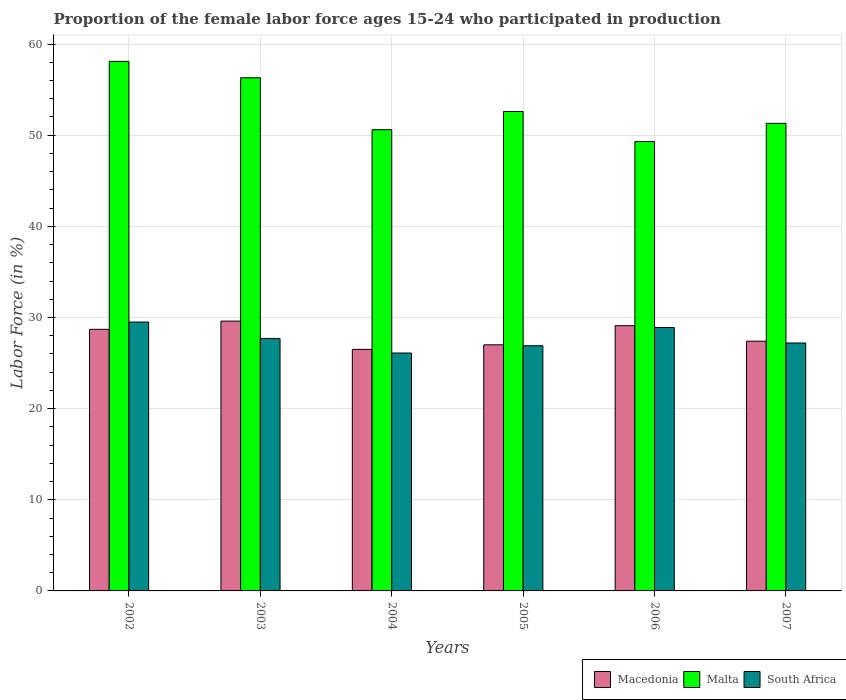How many different coloured bars are there?
Your answer should be compact. 3. Are the number of bars on each tick of the X-axis equal?
Offer a terse response. Yes. In how many cases, is the number of bars for a given year not equal to the number of legend labels?
Make the answer very short. 0. What is the proportion of the female labor force who participated in production in South Africa in 2007?
Give a very brief answer. 27.2. Across all years, what is the maximum proportion of the female labor force who participated in production in Malta?
Make the answer very short. 58.1. Across all years, what is the minimum proportion of the female labor force who participated in production in South Africa?
Provide a short and direct response. 26.1. In which year was the proportion of the female labor force who participated in production in Macedonia maximum?
Your answer should be very brief. 2003. In which year was the proportion of the female labor force who participated in production in South Africa minimum?
Offer a very short reply. 2004. What is the total proportion of the female labor force who participated in production in Macedonia in the graph?
Make the answer very short. 168.3. What is the difference between the proportion of the female labor force who participated in production in South Africa in 2003 and that in 2007?
Make the answer very short. 0.5. What is the difference between the proportion of the female labor force who participated in production in Macedonia in 2007 and the proportion of the female labor force who participated in production in South Africa in 2002?
Provide a succinct answer. -2.1. What is the average proportion of the female labor force who participated in production in Macedonia per year?
Make the answer very short. 28.05. In the year 2003, what is the difference between the proportion of the female labor force who participated in production in Macedonia and proportion of the female labor force who participated in production in South Africa?
Provide a short and direct response. 1.9. In how many years, is the proportion of the female labor force who participated in production in Macedonia greater than 24 %?
Your answer should be very brief. 6. What is the ratio of the proportion of the female labor force who participated in production in Macedonia in 2002 to that in 2003?
Ensure brevity in your answer.  0.97. Is the proportion of the female labor force who participated in production in Macedonia in 2004 less than that in 2006?
Make the answer very short. Yes. What is the difference between the highest and the second highest proportion of the female labor force who participated in production in Malta?
Provide a succinct answer. 1.8. What is the difference between the highest and the lowest proportion of the female labor force who participated in production in South Africa?
Offer a terse response. 3.4. What does the 2nd bar from the left in 2007 represents?
Provide a short and direct response. Malta. What does the 1st bar from the right in 2007 represents?
Keep it short and to the point. South Africa. How many bars are there?
Ensure brevity in your answer.  18. How many years are there in the graph?
Offer a very short reply. 6. What is the difference between two consecutive major ticks on the Y-axis?
Keep it short and to the point. 10. Are the values on the major ticks of Y-axis written in scientific E-notation?
Provide a succinct answer. No. Does the graph contain grids?
Your answer should be very brief. Yes. Where does the legend appear in the graph?
Ensure brevity in your answer.  Bottom right. How many legend labels are there?
Ensure brevity in your answer.  3. How are the legend labels stacked?
Your response must be concise. Horizontal. What is the title of the graph?
Provide a short and direct response. Proportion of the female labor force ages 15-24 who participated in production. Does "Iraq" appear as one of the legend labels in the graph?
Offer a very short reply. No. What is the label or title of the Y-axis?
Provide a short and direct response. Labor Force (in %). What is the Labor Force (in %) in Macedonia in 2002?
Make the answer very short. 28.7. What is the Labor Force (in %) in Malta in 2002?
Provide a short and direct response. 58.1. What is the Labor Force (in %) of South Africa in 2002?
Your answer should be very brief. 29.5. What is the Labor Force (in %) in Macedonia in 2003?
Ensure brevity in your answer.  29.6. What is the Labor Force (in %) in Malta in 2003?
Your answer should be very brief. 56.3. What is the Labor Force (in %) of South Africa in 2003?
Your response must be concise. 27.7. What is the Labor Force (in %) of Macedonia in 2004?
Offer a very short reply. 26.5. What is the Labor Force (in %) in Malta in 2004?
Your answer should be very brief. 50.6. What is the Labor Force (in %) in South Africa in 2004?
Your answer should be compact. 26.1. What is the Labor Force (in %) of Macedonia in 2005?
Give a very brief answer. 27. What is the Labor Force (in %) of Malta in 2005?
Give a very brief answer. 52.6. What is the Labor Force (in %) in South Africa in 2005?
Ensure brevity in your answer.  26.9. What is the Labor Force (in %) of Macedonia in 2006?
Make the answer very short. 29.1. What is the Labor Force (in %) of Malta in 2006?
Ensure brevity in your answer.  49.3. What is the Labor Force (in %) in South Africa in 2006?
Your answer should be compact. 28.9. What is the Labor Force (in %) in Macedonia in 2007?
Your answer should be compact. 27.4. What is the Labor Force (in %) in Malta in 2007?
Your answer should be compact. 51.3. What is the Labor Force (in %) of South Africa in 2007?
Offer a terse response. 27.2. Across all years, what is the maximum Labor Force (in %) in Macedonia?
Keep it short and to the point. 29.6. Across all years, what is the maximum Labor Force (in %) in Malta?
Your response must be concise. 58.1. Across all years, what is the maximum Labor Force (in %) of South Africa?
Your response must be concise. 29.5. Across all years, what is the minimum Labor Force (in %) in Malta?
Your answer should be very brief. 49.3. Across all years, what is the minimum Labor Force (in %) in South Africa?
Your answer should be very brief. 26.1. What is the total Labor Force (in %) in Macedonia in the graph?
Make the answer very short. 168.3. What is the total Labor Force (in %) of Malta in the graph?
Your answer should be compact. 318.2. What is the total Labor Force (in %) of South Africa in the graph?
Ensure brevity in your answer.  166.3. What is the difference between the Labor Force (in %) in South Africa in 2002 and that in 2003?
Your answer should be compact. 1.8. What is the difference between the Labor Force (in %) in Macedonia in 2002 and that in 2004?
Offer a terse response. 2.2. What is the difference between the Labor Force (in %) of Malta in 2002 and that in 2004?
Provide a succinct answer. 7.5. What is the difference between the Labor Force (in %) of Macedonia in 2002 and that in 2005?
Provide a succinct answer. 1.7. What is the difference between the Labor Force (in %) of Macedonia in 2002 and that in 2006?
Your answer should be compact. -0.4. What is the difference between the Labor Force (in %) in Malta in 2002 and that in 2006?
Provide a succinct answer. 8.8. What is the difference between the Labor Force (in %) of Macedonia in 2002 and that in 2007?
Ensure brevity in your answer.  1.3. What is the difference between the Labor Force (in %) in Malta in 2002 and that in 2007?
Provide a short and direct response. 6.8. What is the difference between the Labor Force (in %) in South Africa in 2002 and that in 2007?
Provide a short and direct response. 2.3. What is the difference between the Labor Force (in %) of South Africa in 2003 and that in 2004?
Offer a very short reply. 1.6. What is the difference between the Labor Force (in %) in Macedonia in 2003 and that in 2005?
Keep it short and to the point. 2.6. What is the difference between the Labor Force (in %) of Malta in 2003 and that in 2005?
Give a very brief answer. 3.7. What is the difference between the Labor Force (in %) in South Africa in 2003 and that in 2005?
Your answer should be very brief. 0.8. What is the difference between the Labor Force (in %) of Macedonia in 2003 and that in 2006?
Your response must be concise. 0.5. What is the difference between the Labor Force (in %) in Malta in 2003 and that in 2006?
Provide a short and direct response. 7. What is the difference between the Labor Force (in %) in South Africa in 2003 and that in 2006?
Offer a very short reply. -1.2. What is the difference between the Labor Force (in %) in Macedonia in 2003 and that in 2007?
Your answer should be very brief. 2.2. What is the difference between the Labor Force (in %) of Malta in 2003 and that in 2007?
Offer a terse response. 5. What is the difference between the Labor Force (in %) in South Africa in 2003 and that in 2007?
Ensure brevity in your answer.  0.5. What is the difference between the Labor Force (in %) in Macedonia in 2004 and that in 2005?
Your response must be concise. -0.5. What is the difference between the Labor Force (in %) in South Africa in 2004 and that in 2006?
Offer a very short reply. -2.8. What is the difference between the Labor Force (in %) of South Africa in 2004 and that in 2007?
Your answer should be compact. -1.1. What is the difference between the Labor Force (in %) in Macedonia in 2006 and that in 2007?
Your answer should be very brief. 1.7. What is the difference between the Labor Force (in %) of Malta in 2006 and that in 2007?
Keep it short and to the point. -2. What is the difference between the Labor Force (in %) of Macedonia in 2002 and the Labor Force (in %) of Malta in 2003?
Keep it short and to the point. -27.6. What is the difference between the Labor Force (in %) in Malta in 2002 and the Labor Force (in %) in South Africa in 2003?
Provide a succinct answer. 30.4. What is the difference between the Labor Force (in %) in Macedonia in 2002 and the Labor Force (in %) in Malta in 2004?
Offer a very short reply. -21.9. What is the difference between the Labor Force (in %) of Macedonia in 2002 and the Labor Force (in %) of South Africa in 2004?
Offer a terse response. 2.6. What is the difference between the Labor Force (in %) of Macedonia in 2002 and the Labor Force (in %) of Malta in 2005?
Offer a terse response. -23.9. What is the difference between the Labor Force (in %) of Malta in 2002 and the Labor Force (in %) of South Africa in 2005?
Provide a succinct answer. 31.2. What is the difference between the Labor Force (in %) of Macedonia in 2002 and the Labor Force (in %) of Malta in 2006?
Your answer should be compact. -20.6. What is the difference between the Labor Force (in %) of Macedonia in 2002 and the Labor Force (in %) of South Africa in 2006?
Make the answer very short. -0.2. What is the difference between the Labor Force (in %) of Malta in 2002 and the Labor Force (in %) of South Africa in 2006?
Keep it short and to the point. 29.2. What is the difference between the Labor Force (in %) in Macedonia in 2002 and the Labor Force (in %) in Malta in 2007?
Make the answer very short. -22.6. What is the difference between the Labor Force (in %) in Malta in 2002 and the Labor Force (in %) in South Africa in 2007?
Keep it short and to the point. 30.9. What is the difference between the Labor Force (in %) in Malta in 2003 and the Labor Force (in %) in South Africa in 2004?
Offer a very short reply. 30.2. What is the difference between the Labor Force (in %) in Macedonia in 2003 and the Labor Force (in %) in Malta in 2005?
Offer a terse response. -23. What is the difference between the Labor Force (in %) of Macedonia in 2003 and the Labor Force (in %) of South Africa in 2005?
Provide a succinct answer. 2.7. What is the difference between the Labor Force (in %) of Malta in 2003 and the Labor Force (in %) of South Africa in 2005?
Give a very brief answer. 29.4. What is the difference between the Labor Force (in %) in Macedonia in 2003 and the Labor Force (in %) in Malta in 2006?
Your answer should be very brief. -19.7. What is the difference between the Labor Force (in %) in Malta in 2003 and the Labor Force (in %) in South Africa in 2006?
Offer a terse response. 27.4. What is the difference between the Labor Force (in %) in Macedonia in 2003 and the Labor Force (in %) in Malta in 2007?
Ensure brevity in your answer.  -21.7. What is the difference between the Labor Force (in %) in Malta in 2003 and the Labor Force (in %) in South Africa in 2007?
Your response must be concise. 29.1. What is the difference between the Labor Force (in %) of Macedonia in 2004 and the Labor Force (in %) of Malta in 2005?
Provide a short and direct response. -26.1. What is the difference between the Labor Force (in %) in Malta in 2004 and the Labor Force (in %) in South Africa in 2005?
Keep it short and to the point. 23.7. What is the difference between the Labor Force (in %) in Macedonia in 2004 and the Labor Force (in %) in Malta in 2006?
Keep it short and to the point. -22.8. What is the difference between the Labor Force (in %) in Malta in 2004 and the Labor Force (in %) in South Africa in 2006?
Keep it short and to the point. 21.7. What is the difference between the Labor Force (in %) in Macedonia in 2004 and the Labor Force (in %) in Malta in 2007?
Ensure brevity in your answer.  -24.8. What is the difference between the Labor Force (in %) of Macedonia in 2004 and the Labor Force (in %) of South Africa in 2007?
Your answer should be compact. -0.7. What is the difference between the Labor Force (in %) in Malta in 2004 and the Labor Force (in %) in South Africa in 2007?
Your response must be concise. 23.4. What is the difference between the Labor Force (in %) of Macedonia in 2005 and the Labor Force (in %) of Malta in 2006?
Offer a terse response. -22.3. What is the difference between the Labor Force (in %) in Macedonia in 2005 and the Labor Force (in %) in South Africa in 2006?
Your answer should be very brief. -1.9. What is the difference between the Labor Force (in %) in Malta in 2005 and the Labor Force (in %) in South Africa in 2006?
Offer a terse response. 23.7. What is the difference between the Labor Force (in %) in Macedonia in 2005 and the Labor Force (in %) in Malta in 2007?
Make the answer very short. -24.3. What is the difference between the Labor Force (in %) in Macedonia in 2005 and the Labor Force (in %) in South Africa in 2007?
Offer a very short reply. -0.2. What is the difference between the Labor Force (in %) in Malta in 2005 and the Labor Force (in %) in South Africa in 2007?
Keep it short and to the point. 25.4. What is the difference between the Labor Force (in %) of Macedonia in 2006 and the Labor Force (in %) of Malta in 2007?
Your answer should be compact. -22.2. What is the difference between the Labor Force (in %) in Macedonia in 2006 and the Labor Force (in %) in South Africa in 2007?
Make the answer very short. 1.9. What is the difference between the Labor Force (in %) in Malta in 2006 and the Labor Force (in %) in South Africa in 2007?
Your answer should be very brief. 22.1. What is the average Labor Force (in %) of Macedonia per year?
Your response must be concise. 28.05. What is the average Labor Force (in %) of Malta per year?
Make the answer very short. 53.03. What is the average Labor Force (in %) of South Africa per year?
Keep it short and to the point. 27.72. In the year 2002, what is the difference between the Labor Force (in %) of Macedonia and Labor Force (in %) of Malta?
Offer a very short reply. -29.4. In the year 2002, what is the difference between the Labor Force (in %) in Macedonia and Labor Force (in %) in South Africa?
Your answer should be compact. -0.8. In the year 2002, what is the difference between the Labor Force (in %) of Malta and Labor Force (in %) of South Africa?
Your response must be concise. 28.6. In the year 2003, what is the difference between the Labor Force (in %) in Macedonia and Labor Force (in %) in Malta?
Your answer should be compact. -26.7. In the year 2003, what is the difference between the Labor Force (in %) in Macedonia and Labor Force (in %) in South Africa?
Provide a short and direct response. 1.9. In the year 2003, what is the difference between the Labor Force (in %) of Malta and Labor Force (in %) of South Africa?
Provide a short and direct response. 28.6. In the year 2004, what is the difference between the Labor Force (in %) of Macedonia and Labor Force (in %) of Malta?
Your response must be concise. -24.1. In the year 2004, what is the difference between the Labor Force (in %) of Macedonia and Labor Force (in %) of South Africa?
Keep it short and to the point. 0.4. In the year 2004, what is the difference between the Labor Force (in %) in Malta and Labor Force (in %) in South Africa?
Offer a very short reply. 24.5. In the year 2005, what is the difference between the Labor Force (in %) in Macedonia and Labor Force (in %) in Malta?
Make the answer very short. -25.6. In the year 2005, what is the difference between the Labor Force (in %) in Macedonia and Labor Force (in %) in South Africa?
Your answer should be compact. 0.1. In the year 2005, what is the difference between the Labor Force (in %) in Malta and Labor Force (in %) in South Africa?
Keep it short and to the point. 25.7. In the year 2006, what is the difference between the Labor Force (in %) of Macedonia and Labor Force (in %) of Malta?
Keep it short and to the point. -20.2. In the year 2006, what is the difference between the Labor Force (in %) of Macedonia and Labor Force (in %) of South Africa?
Your response must be concise. 0.2. In the year 2006, what is the difference between the Labor Force (in %) in Malta and Labor Force (in %) in South Africa?
Keep it short and to the point. 20.4. In the year 2007, what is the difference between the Labor Force (in %) of Macedonia and Labor Force (in %) of Malta?
Keep it short and to the point. -23.9. In the year 2007, what is the difference between the Labor Force (in %) in Macedonia and Labor Force (in %) in South Africa?
Your response must be concise. 0.2. In the year 2007, what is the difference between the Labor Force (in %) of Malta and Labor Force (in %) of South Africa?
Your response must be concise. 24.1. What is the ratio of the Labor Force (in %) in Macedonia in 2002 to that in 2003?
Ensure brevity in your answer.  0.97. What is the ratio of the Labor Force (in %) of Malta in 2002 to that in 2003?
Offer a terse response. 1.03. What is the ratio of the Labor Force (in %) in South Africa in 2002 to that in 2003?
Offer a terse response. 1.06. What is the ratio of the Labor Force (in %) in Macedonia in 2002 to that in 2004?
Provide a short and direct response. 1.08. What is the ratio of the Labor Force (in %) in Malta in 2002 to that in 2004?
Your answer should be very brief. 1.15. What is the ratio of the Labor Force (in %) of South Africa in 2002 to that in 2004?
Make the answer very short. 1.13. What is the ratio of the Labor Force (in %) of Macedonia in 2002 to that in 2005?
Offer a very short reply. 1.06. What is the ratio of the Labor Force (in %) of Malta in 2002 to that in 2005?
Provide a short and direct response. 1.1. What is the ratio of the Labor Force (in %) in South Africa in 2002 to that in 2005?
Your answer should be very brief. 1.1. What is the ratio of the Labor Force (in %) in Macedonia in 2002 to that in 2006?
Give a very brief answer. 0.99. What is the ratio of the Labor Force (in %) in Malta in 2002 to that in 2006?
Provide a succinct answer. 1.18. What is the ratio of the Labor Force (in %) in South Africa in 2002 to that in 2006?
Make the answer very short. 1.02. What is the ratio of the Labor Force (in %) in Macedonia in 2002 to that in 2007?
Your answer should be compact. 1.05. What is the ratio of the Labor Force (in %) in Malta in 2002 to that in 2007?
Your response must be concise. 1.13. What is the ratio of the Labor Force (in %) of South Africa in 2002 to that in 2007?
Your answer should be very brief. 1.08. What is the ratio of the Labor Force (in %) in Macedonia in 2003 to that in 2004?
Your answer should be very brief. 1.12. What is the ratio of the Labor Force (in %) of Malta in 2003 to that in 2004?
Your response must be concise. 1.11. What is the ratio of the Labor Force (in %) in South Africa in 2003 to that in 2004?
Give a very brief answer. 1.06. What is the ratio of the Labor Force (in %) in Macedonia in 2003 to that in 2005?
Provide a short and direct response. 1.1. What is the ratio of the Labor Force (in %) in Malta in 2003 to that in 2005?
Your answer should be very brief. 1.07. What is the ratio of the Labor Force (in %) in South Africa in 2003 to that in 2005?
Your answer should be very brief. 1.03. What is the ratio of the Labor Force (in %) in Macedonia in 2003 to that in 2006?
Your response must be concise. 1.02. What is the ratio of the Labor Force (in %) of Malta in 2003 to that in 2006?
Provide a succinct answer. 1.14. What is the ratio of the Labor Force (in %) in South Africa in 2003 to that in 2006?
Provide a short and direct response. 0.96. What is the ratio of the Labor Force (in %) of Macedonia in 2003 to that in 2007?
Give a very brief answer. 1.08. What is the ratio of the Labor Force (in %) in Malta in 2003 to that in 2007?
Offer a very short reply. 1.1. What is the ratio of the Labor Force (in %) of South Africa in 2003 to that in 2007?
Provide a succinct answer. 1.02. What is the ratio of the Labor Force (in %) of Macedonia in 2004 to that in 2005?
Your answer should be very brief. 0.98. What is the ratio of the Labor Force (in %) of Malta in 2004 to that in 2005?
Your answer should be very brief. 0.96. What is the ratio of the Labor Force (in %) of South Africa in 2004 to that in 2005?
Give a very brief answer. 0.97. What is the ratio of the Labor Force (in %) of Macedonia in 2004 to that in 2006?
Offer a very short reply. 0.91. What is the ratio of the Labor Force (in %) of Malta in 2004 to that in 2006?
Offer a terse response. 1.03. What is the ratio of the Labor Force (in %) of South Africa in 2004 to that in 2006?
Keep it short and to the point. 0.9. What is the ratio of the Labor Force (in %) in Macedonia in 2004 to that in 2007?
Your answer should be very brief. 0.97. What is the ratio of the Labor Force (in %) of Malta in 2004 to that in 2007?
Ensure brevity in your answer.  0.99. What is the ratio of the Labor Force (in %) of South Africa in 2004 to that in 2007?
Your answer should be very brief. 0.96. What is the ratio of the Labor Force (in %) in Macedonia in 2005 to that in 2006?
Provide a short and direct response. 0.93. What is the ratio of the Labor Force (in %) of Malta in 2005 to that in 2006?
Make the answer very short. 1.07. What is the ratio of the Labor Force (in %) in South Africa in 2005 to that in 2006?
Offer a very short reply. 0.93. What is the ratio of the Labor Force (in %) in Macedonia in 2005 to that in 2007?
Your answer should be compact. 0.99. What is the ratio of the Labor Force (in %) of Malta in 2005 to that in 2007?
Your answer should be very brief. 1.03. What is the ratio of the Labor Force (in %) in South Africa in 2005 to that in 2007?
Offer a very short reply. 0.99. What is the ratio of the Labor Force (in %) in Macedonia in 2006 to that in 2007?
Your answer should be compact. 1.06. What is the ratio of the Labor Force (in %) in Malta in 2006 to that in 2007?
Ensure brevity in your answer.  0.96. What is the difference between the highest and the second highest Labor Force (in %) of South Africa?
Offer a very short reply. 0.6. 